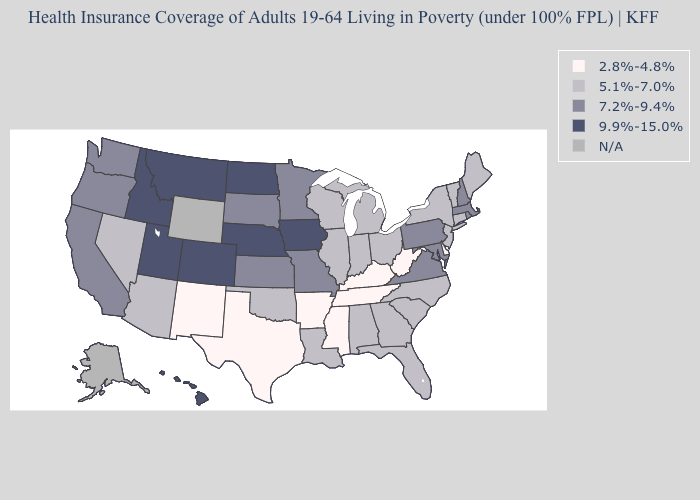What is the lowest value in the USA?
Write a very short answer. 2.8%-4.8%. What is the lowest value in the South?
Write a very short answer. 2.8%-4.8%. What is the value of South Carolina?
Keep it brief. 5.1%-7.0%. Does Nebraska have the highest value in the MidWest?
Give a very brief answer. Yes. Name the states that have a value in the range N/A?
Be succinct. Alaska, Wyoming. Name the states that have a value in the range 7.2%-9.4%?
Be succinct. California, Kansas, Maryland, Massachusetts, Minnesota, Missouri, New Hampshire, Oregon, Pennsylvania, Rhode Island, South Dakota, Virginia, Washington. Does the first symbol in the legend represent the smallest category?
Short answer required. Yes. Name the states that have a value in the range 5.1%-7.0%?
Quick response, please. Alabama, Arizona, Connecticut, Florida, Georgia, Illinois, Indiana, Louisiana, Maine, Michigan, Nevada, New Jersey, New York, North Carolina, Ohio, Oklahoma, South Carolina, Vermont, Wisconsin. What is the lowest value in the USA?
Quick response, please. 2.8%-4.8%. What is the lowest value in the USA?
Concise answer only. 2.8%-4.8%. What is the value of Tennessee?
Concise answer only. 2.8%-4.8%. What is the lowest value in the USA?
Quick response, please. 2.8%-4.8%. What is the value of Iowa?
Answer briefly. 9.9%-15.0%. Name the states that have a value in the range 9.9%-15.0%?
Short answer required. Colorado, Hawaii, Idaho, Iowa, Montana, Nebraska, North Dakota, Utah. 